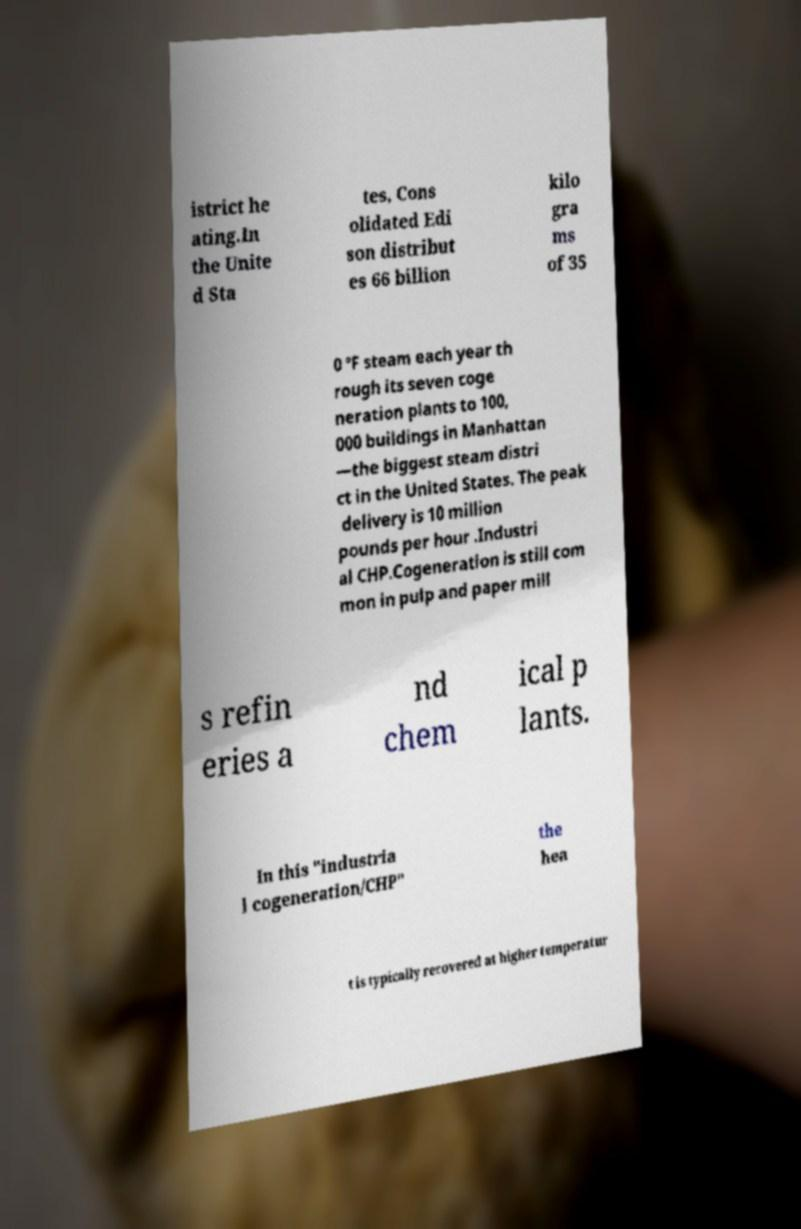Please identify and transcribe the text found in this image. istrict he ating.In the Unite d Sta tes, Cons olidated Edi son distribut es 66 billion kilo gra ms of 35 0 °F steam each year th rough its seven coge neration plants to 100, 000 buildings in Manhattan —the biggest steam distri ct in the United States. The peak delivery is 10 million pounds per hour .Industri al CHP.Cogeneration is still com mon in pulp and paper mill s refin eries a nd chem ical p lants. In this "industria l cogeneration/CHP" the hea t is typically recovered at higher temperatur 